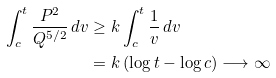<formula> <loc_0><loc_0><loc_500><loc_500>\int _ { c } ^ { t } \frac { P ^ { 2 } } { Q ^ { 5 / 2 } } \, d v & \geq k \int _ { c } ^ { t } \frac { 1 } { v } \, d v \\ & = k \left ( \log t - \log c \right ) \longrightarrow \infty</formula> 